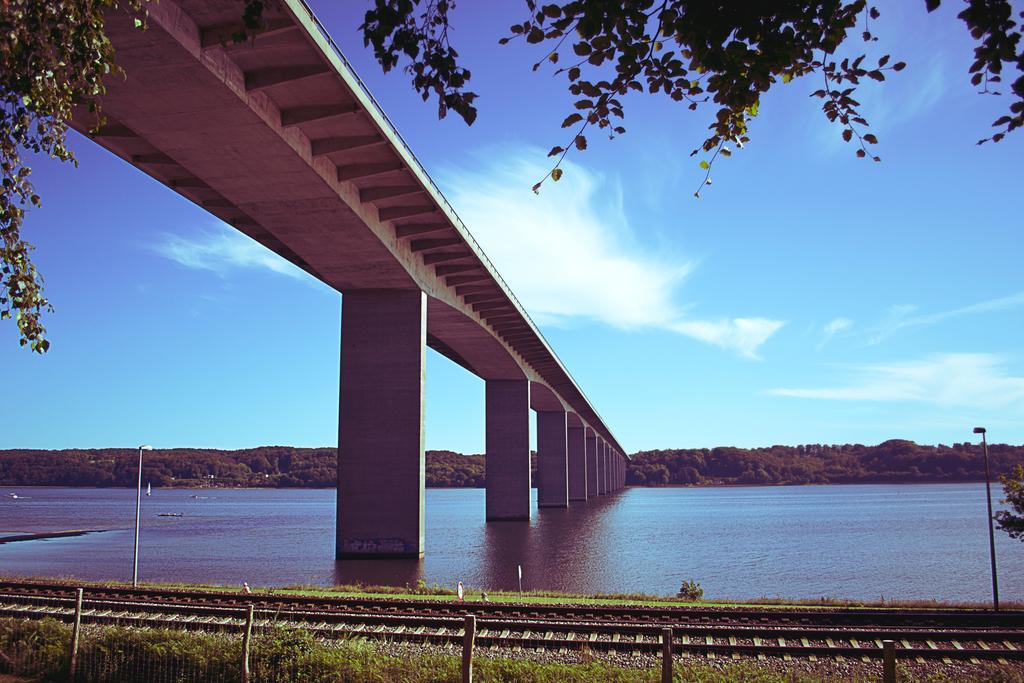How would you summarize this image in a sentence or two? In this image in front there are poles. There is a railway track. In the center of the image there is a bridge. There are ships in the water. In the background of the image there are trees and sky. 